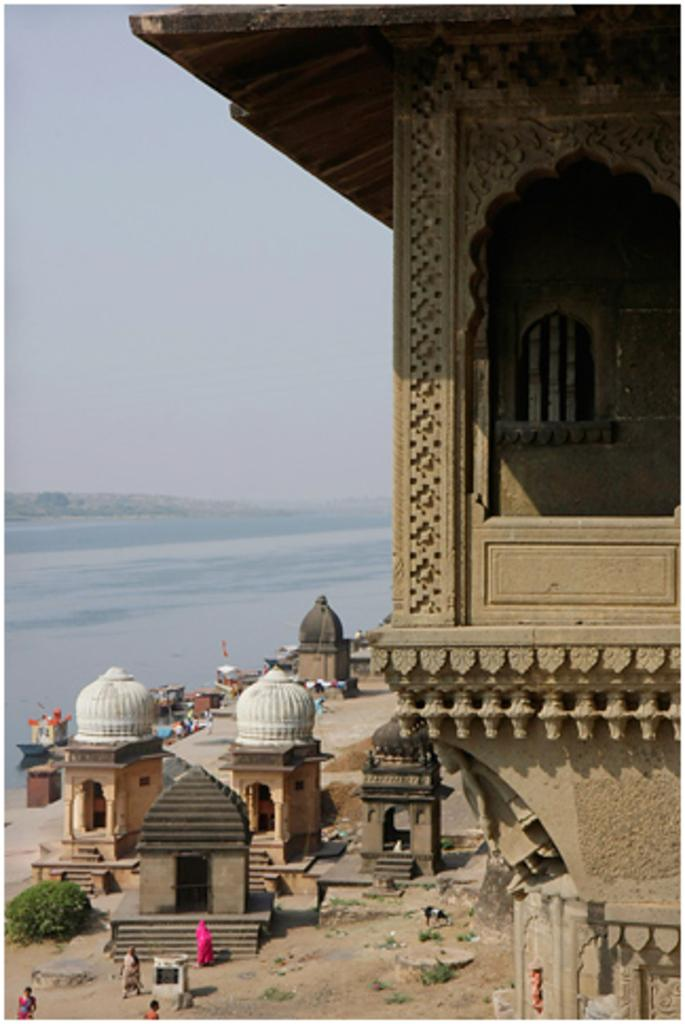What are the people in the image doing? The people in the image are standing on the ground. What type of structures can be seen in the image? There are tombs and buildings in the image. What natural feature is visible in the background of the image? There is an ocean visible in the background of the image. How would you describe the weather in the image? The sky is clear in the image, suggesting good weather. How many rings are visible on the people's fingers in the image? There is no information about rings on the people's fingers in the image, so we cannot determine the number of rings. What type of ray is swimming in the ocean in the image? There is no ray visible in the ocean in the image. 